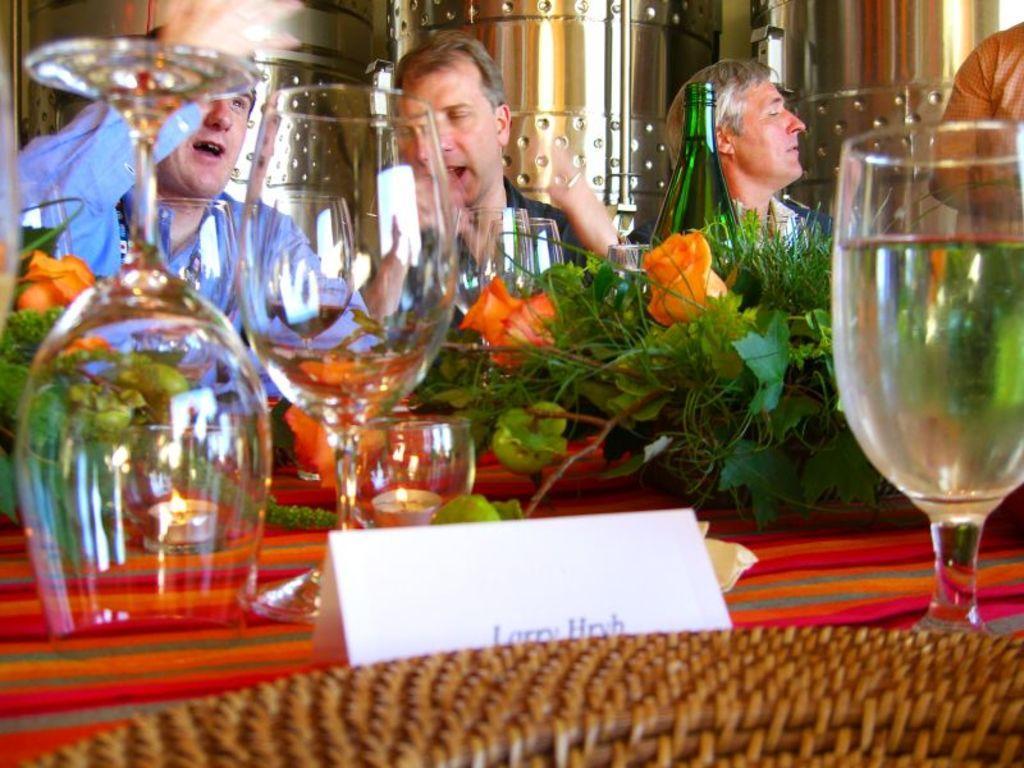Describe this image in one or two sentences. In this image we can see few people. There are glasses and flower bouquets. Also there is a bottle and name board. At the bottom we can see part of a basket. 